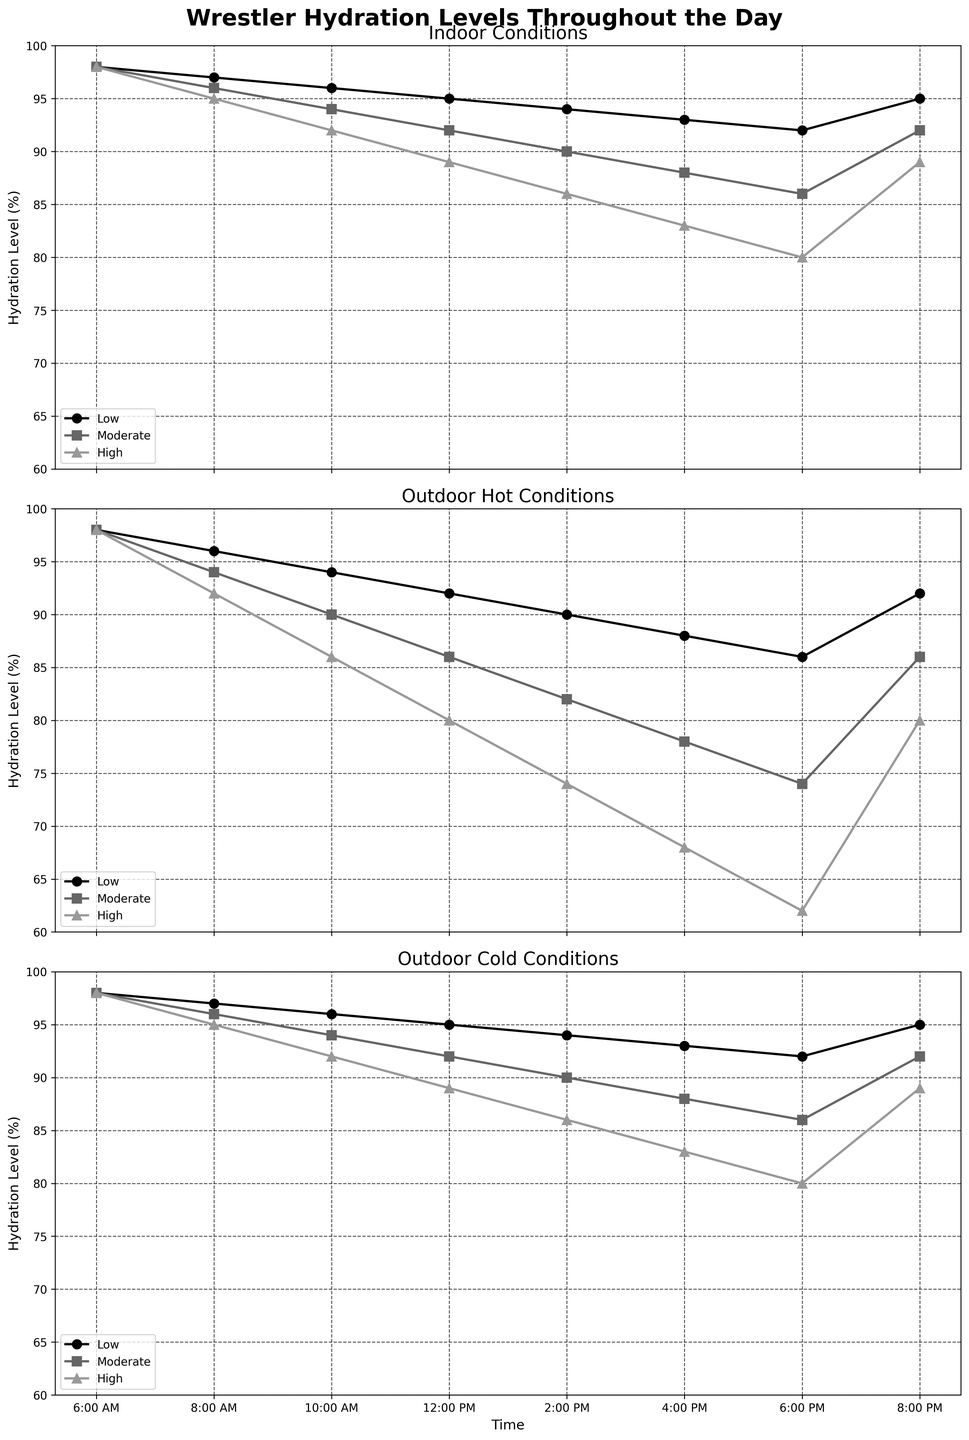What's the hydration level for high-intensity activity indoors at 4:00 PM? Look for the high-intensity line in the Indoor Conditions subplot at the 4:00 PM mark.
Answer: 83 Which condition shows the lowest hydration level at 6:00 PM? Compare the hydration levels across all training intensities for each condition at 6:00 PM. The Outdoor Hot condition has the lowest hydration level at 62 for high intensity.
Answer: Outdoor Hot How does low-intensity hydration indoors at 12:00 PM compare to outdoor cold conditions at the same time? Check the hydration levels for low intensity at 12:00 PM for both conditions. Indoor low intensity is at 95%, whereas outdoor cold low intensity is also at 95%.
Answer: The same, 95% What is the average hydration level for moderate intensity in Outdoor Hot conditions throughout the day? Add up the hydration levels for moderate intensity in Outdoor Hot conditions and divide by the number of time points (8: 98 + 94 + 90 + 86 + 82 + 78 + 74 + 86 = 688). Then divide by the number of time points 688 / 8 = 86
Answer: 86 Which training intensity has the steepest decline in hydration by 6:00 PM in Outdoor Hot conditions? Compare the drop in hydration levels from 6:00 AM to 6:00 PM for low, moderate, and high intensities in Outdoor Hot conditions. Low intensity drops from 98 to 86 (12 units), moderate from 98 to 74 (24 units), and high from 98 to 62 (36 units).
Answer: High intensity At which time point is the hydration level for low-intensity outdoor cold conditions highest? Look for the highest value in the low-intensity line for Outdoor Cold conditions across all time points.
Answer: 6:00 AM, 8:00 PM How much does the hydration level for high-intensity training indoor conditions change between 10:00 AM and 2:00 PM? Subtract the hydration level at 2:00 PM from that at 10:00 AM for high-intensity indoor conditions. 92 - 86 = 6
Answer: 6 During which time period do we observe the largest difference between moderate intensity indoor and moderate intensity outdoor cold condition? Compare values for moderate intensity indoor and outdoor cold conditions across all time points and identify the maximum difference. At 2:00 PM, the difference is the largest (90 - 86 = 4).
Answer: 2:00 PM 